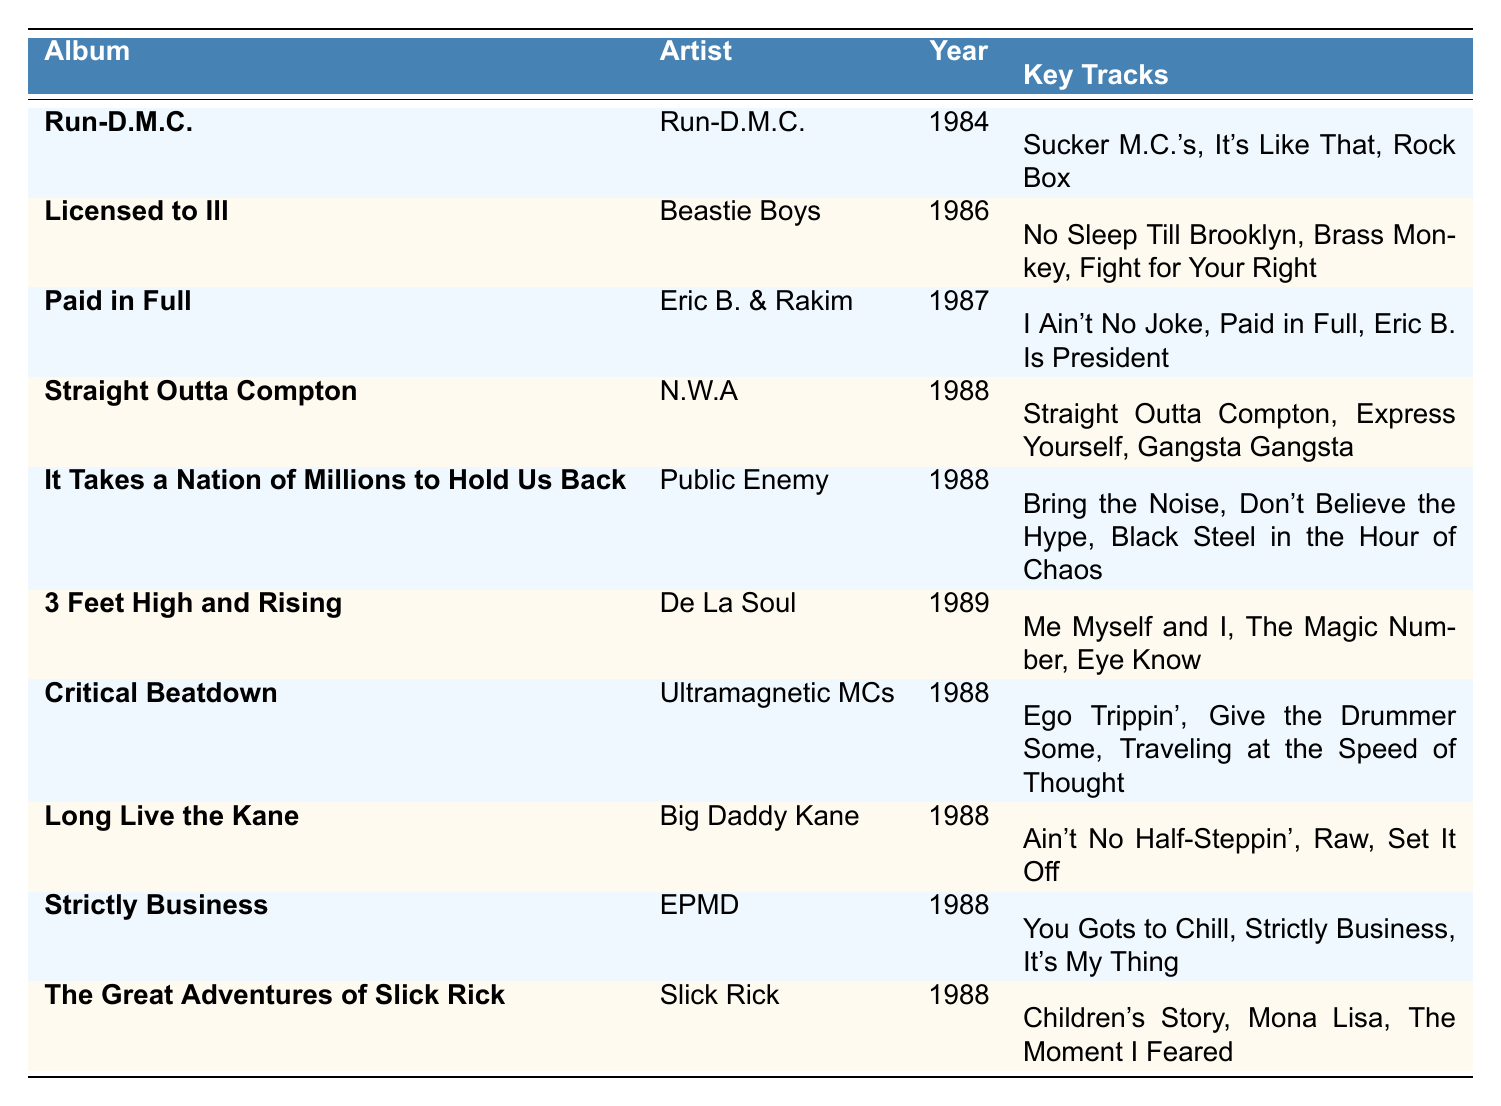What is the title of the album released by Eric B. & Rakim in 1987? From the table, under the Artist "Eric B. & Rakim" in the Year column of 1987, the corresponding Album is "Paid in Full."
Answer: Paid in Full Which artist released the album "Straight Outta Compton"? Looking at the row with the Album "Straight Outta Compton," the Artist listed is "N.W.A."
Answer: N.W.A How many albums are listed from the year 1988? Counting the rows for the Year column, there are six albums listed from 1988: "Straight Outta Compton," "It Takes a Nation of Millions to Hold Us Back," "Critical Beatdown," "Long Live the Kane," "Strictly Business," and "The Great Adventures of Slick Rick."
Answer: 6 Which album has the key track "Children's Story"? Referencing the Key Tracks column, "Children's Story" is found under the Album "The Great Adventures of Slick Rick."
Answer: The Great Adventures of Slick Rick What is the average year of the albums in this table? To find the average, sum the years: (1984 + 1986 + 1987 + 1988 + 1988 + 1989 + 1988 + 1988 + 1988 + 1988) = 1987. The total number of albums is 10, so the average year is 1987/10 = 1987.
Answer: 1987 Was there an album released by Big Daddy Kane in 1988? Referring to the table, Big Daddy Kane did release the album "Long Live the Kane" in 1988, verifying the statement is true.
Answer: Yes Which album includes the key tracks "Rock Box" and "Sucker M.C.'s"? These key tracks are found in the row for the Album "Run-D.M.C." which is by the artist Run-D.M.C.
Answer: Run-D.M.C List the artists who released albums in 1988. The artists with albums in 1988 from the table are N.W.A, Public Enemy, Ultramagnetic MCs, Big Daddy Kane, EPMD, and Slick Rick. This amounts to six different artists.
Answer: N.W.A, Public Enemy, Ultramagnetic MCs, Big Daddy Kane, EPMD, Slick Rick 